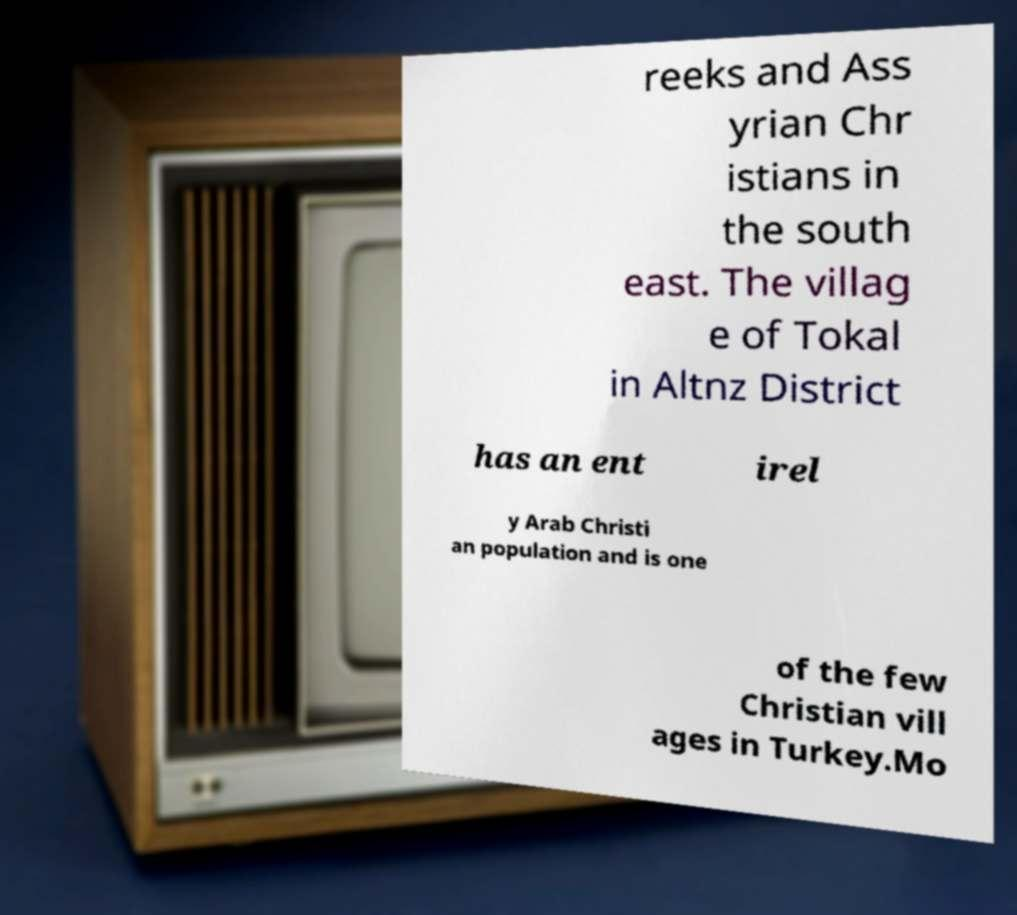Could you assist in decoding the text presented in this image and type it out clearly? reeks and Ass yrian Chr istians in the south east. The villag e of Tokal in Altnz District has an ent irel y Arab Christi an population and is one of the few Christian vill ages in Turkey.Mo 